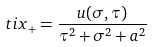Convert formula to latex. <formula><loc_0><loc_0><loc_500><loc_500>\ t i { x } _ { + } = \frac { u ( \sigma , \tau ) } { \tau ^ { 2 } + \sigma ^ { 2 } + a ^ { 2 } }</formula> 